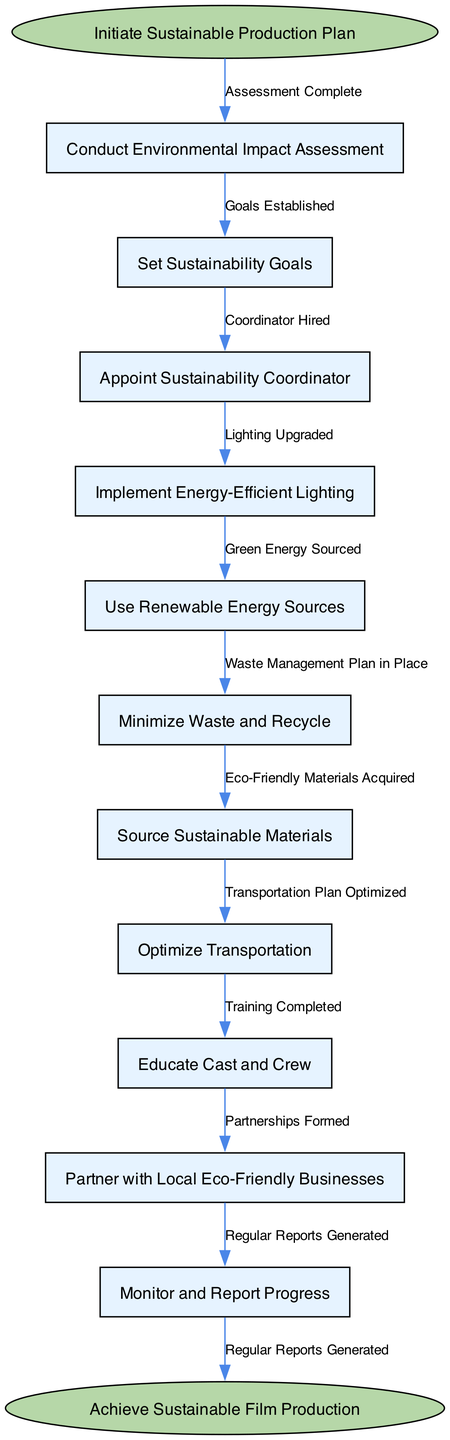What is the starting point of the flow chart? The starting point is labeled as "Initiate Sustainable Production Plan," which is the first node in the flow chart.
Answer: Initiate Sustainable Production Plan How many total nodes are in the diagram? There is a total of 12 nodes, which include the start node, 10 process nodes, and the end node.
Answer: 12 Which node follows the "Conduct Environmental Impact Assessment"? The node that follows "Conduct Environmental Impact Assessment" is "Set Sustainability Goals," as indicated by the directed edge between these two nodes.
Answer: Set Sustainability Goals What is the final outcome indicated in the flow chart? The final outcome is labeled as "Achieve Sustainable Film Production," representing the end point of the flow chart.
Answer: Achieve Sustainable Film Production What is the role of the Sustainability Coordinator in the process? The appointed Sustainability Coordinator leads the sustainability efforts, ensuring that the goals are met and processes are followed, which directly follows the appointment step in the flow chart.
Answer: Coordinator Hired How many edges connect the start node to other nodes? There is one edge that connects the start node to "Conduct Environmental Impact Assessment," indicating the first action in the process.
Answer: 1 What is the immediate node after "Optimize Transportation"? The immediate node after "Optimize Transportation" is "Educate Cast and Crew," as shown in the flow of the diagram.
Answer: Educate Cast and Crew What task is performed after "Monitor and Report Progress"? "Achieve Sustainable Film Production" is the task that signifies the conclusion of the flow chart, coming after the monitoring and reporting processes.
Answer: Achieve Sustainable Film Production Which node is linked to the edge labeled "Eco-Friendly Materials Acquired"? The edge labeled "Eco-Friendly Materials Acquired" connects the node "Source Sustainable Materials" to the next step in the process, which is the subsequent node in the sequence.
Answer: Source Sustainable Materials 